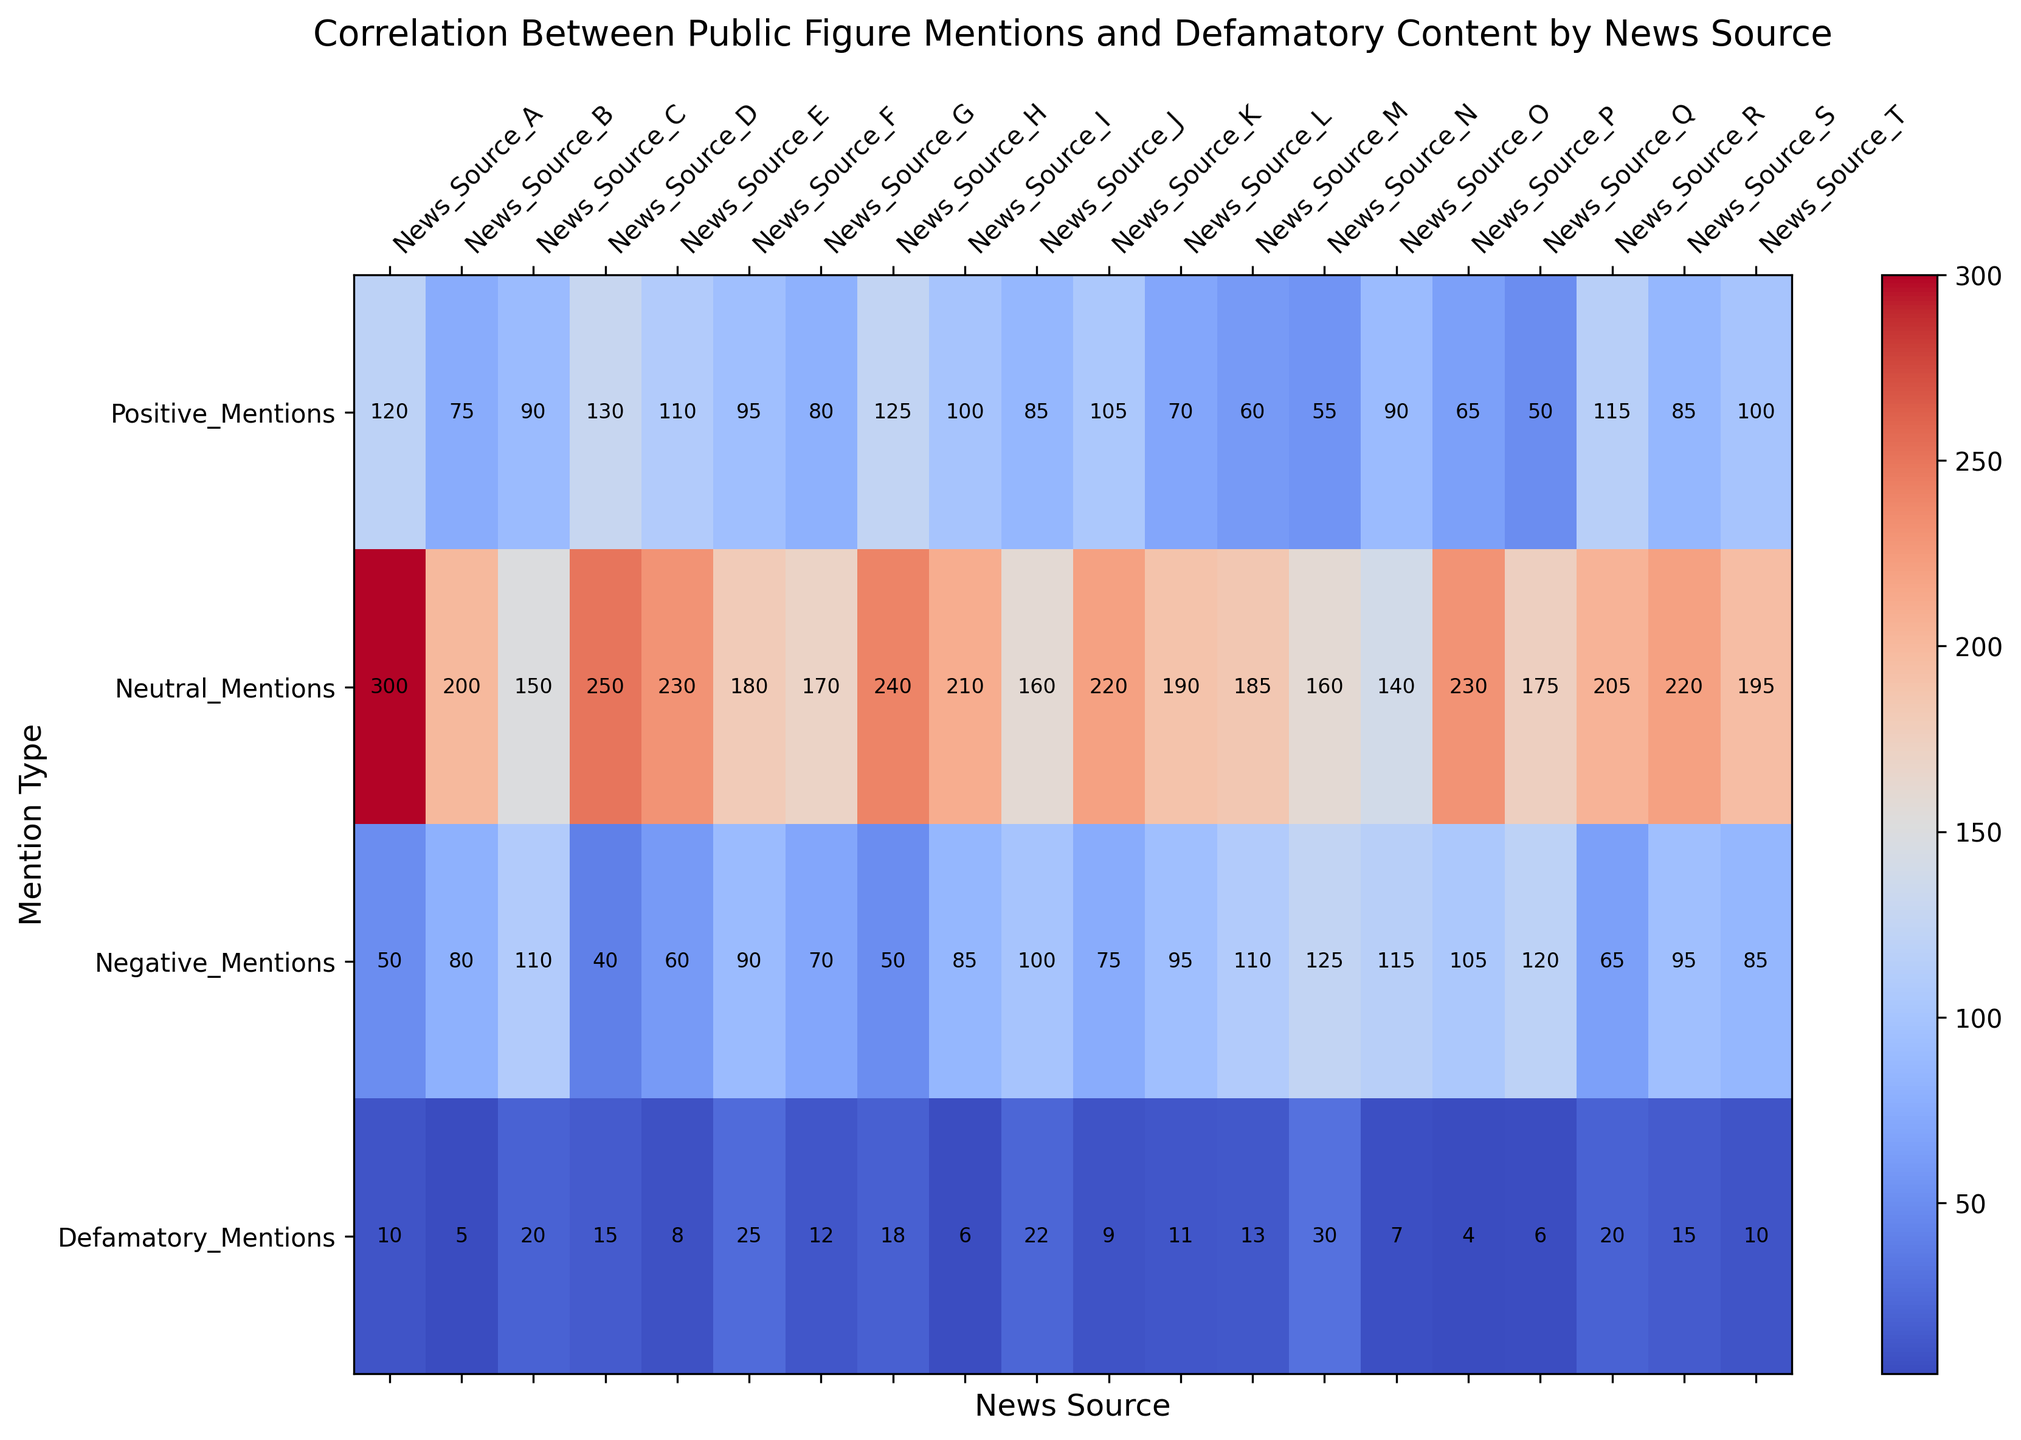What news source has the highest number of defamatory mentions? First, identify the row labeled "Defamatory_Mentions". Then, scan across the columns to find the highest number in this row.
Answer: News_Source_N Which news source has more positive mentions, News_Source_F or News_Source_G? Look at the "Positive_Mentions" row and compare the values for News_Source_F and News_Source_G.
Answer: News_Source_F What is the total number of positive mentions from News_Source_A and News_Source_D? Add the values in the "Positive_Mentions" row for News_Source_A and News_Source_D: 120 + 130.
Answer: 250 Which news source has the fewest neutral mentions? Identify the row labeled "Neutral_Mentions" and find the smallest value in this row. Note the corresponding news source.
Answer: News_Source_O What is the difference in negative mentions between News_Source_J and News_Source_L? Identify the values in the "Negative_Mentions" row for News_Source_J and News_Source_L. Subtract the negative mentions for News_Source_L from those for News_Source_J: 100 - 95.
Answer: 5 Which two news sources have an equal number of negative mentions? Look across the "Negative_Mentions" row and identify two columns with the same values.
Answer: News_Source_T and News_Source_I Which news source has the most mentions in total across all categories? Sum the counts of all types of mentions for each news source and identify the highest sum. The calculations involve adding the Positive, Neutral, Negative, and Defamatory mentions for each source and comparing the totals. News_Source_H has the most total mentions: 125 (Positive) + 240 (Neutral) + 50 (Negative) + 18 (Defamatory) = 433.
Answer: News_Source_H What is the average number of defamatory mentions across all news sources? Sum the values in the "Defamatory_Mentions" row. Then divide by the number of news sources (20). The sum is 248, and there are 20 sources, so the average is 248/20.
Answer: 12.4 Which category type has the highest count for News_Source_A? Compare the values in each category (Positive, Neutral, Negative, Defamatory) for News_Source_A. The highest count will be 300 in the "Neutral_Mentions" row.
Answer: Neutral 